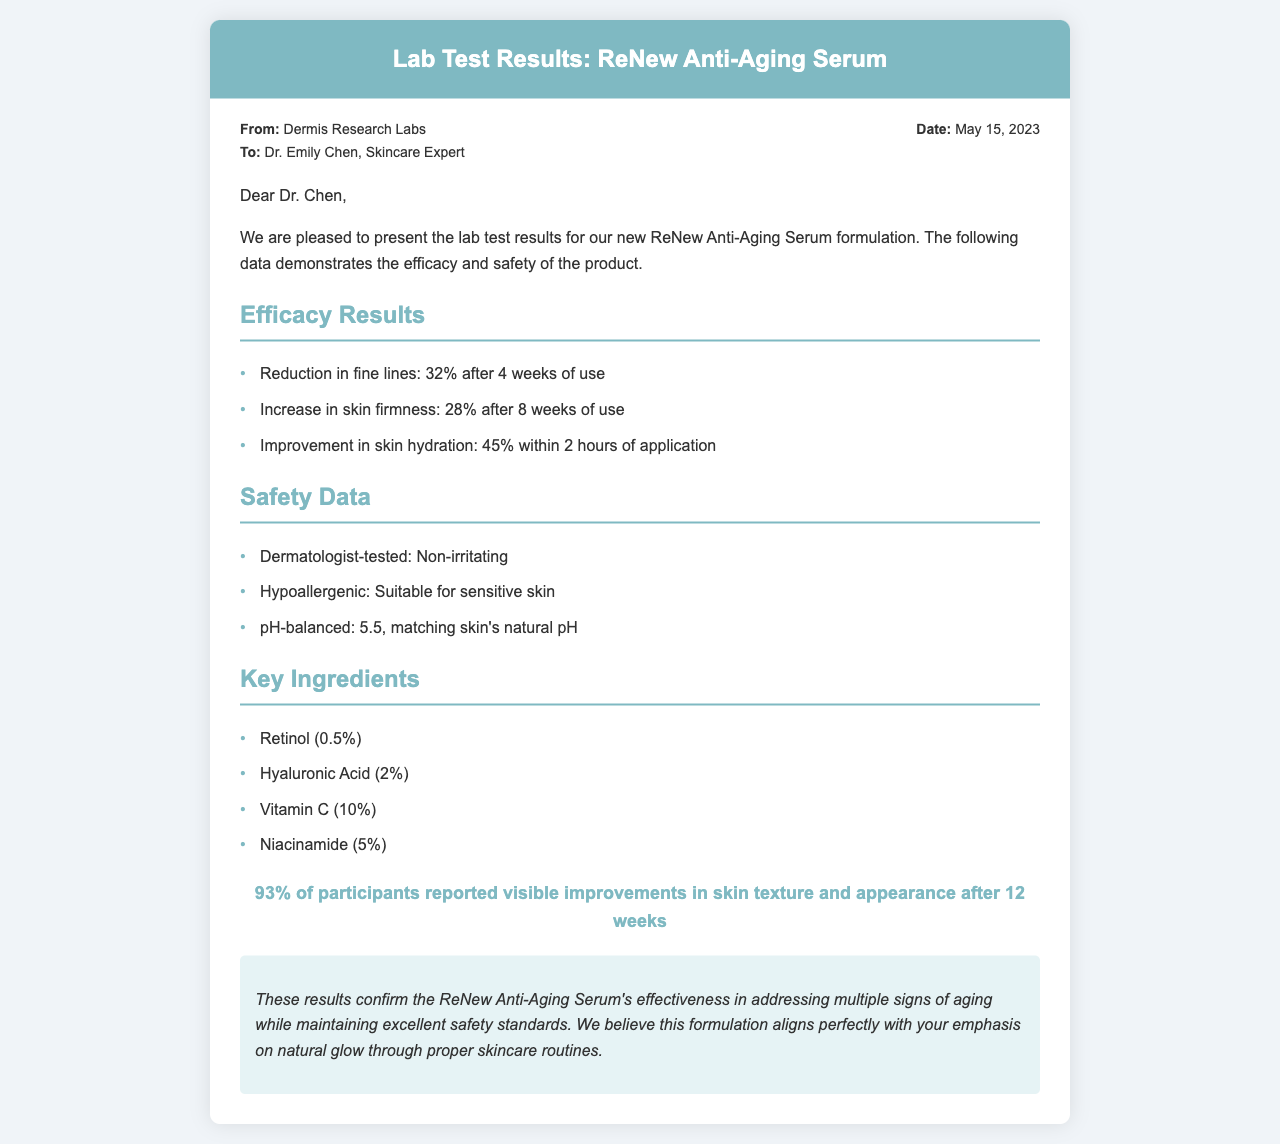What is the reduction in fine lines after 4 weeks? The reduction in fine lines is stated in the efficacy results section as 32% after 4 weeks of use.
Answer: 32% What percentage of participants reported improvements in skin texture? The satisfaction section provides this information stating that 93% of participants reported visible improvements.
Answer: 93% What is the pH balance of the serum? The safety data specifies that the serum is pH-balanced at 5.5, which matches the skin's natural pH.
Answer: 5.5 How long does it take for the serum to improve skin hydration? The efficacy results mention that skin hydration improves by 45% within 2 hours of application.
Answer: 2 hours List one key ingredient in the ReNew Anti-Aging Serum. The key ingredients section enumerates several ingredients, and one listed is retinol at 0.5%.
Answer: Retinol (0.5%) What is the conclusion regarding the ReNew Anti-Aging Serum? The conclusion summarizes the effectiveness of the serum while emphasizing safety, specifically stating it addresses multiple signs of aging.
Answer: Effectiveness in addressing multiple signs of aging Who tested the serum for safety? The safety data states that the serum is dermatologist-tested to be non-irritating.
Answer: Dermatologist-tested What is the date of the lab test results document? The meta section contains the date, which is provided as May 15, 2023.
Answer: May 15, 2023 How much did skin firmness increase after 8 weeks? The efficacy results section indicates an increase in skin firmness of 28% after 8 weeks.
Answer: 28% 